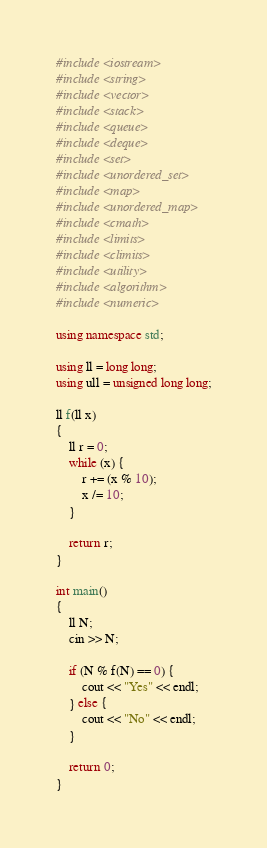Convert code to text. <code><loc_0><loc_0><loc_500><loc_500><_C++_>#include <iostream>
#include <string>
#include <vector>
#include <stack>
#include <queue>
#include <deque>
#include <set>
#include <unordered_set>
#include <map>
#include <unordered_map>
#include <cmath>
#include <limits>
#include <climits>
#include <utility>
#include <algorithm>
#include <numeric>

using namespace std;

using ll = long long;
using ull = unsigned long long;

ll f(ll x)
{
    ll r = 0;
    while (x) {
        r += (x % 10);
        x /= 10;
    }

    return r;
}

int main()
{
    ll N;
    cin >> N;

    if (N % f(N) == 0) {
        cout << "Yes" << endl;
    } else {
        cout << "No" << endl;
    }

    return 0;
}
</code> 